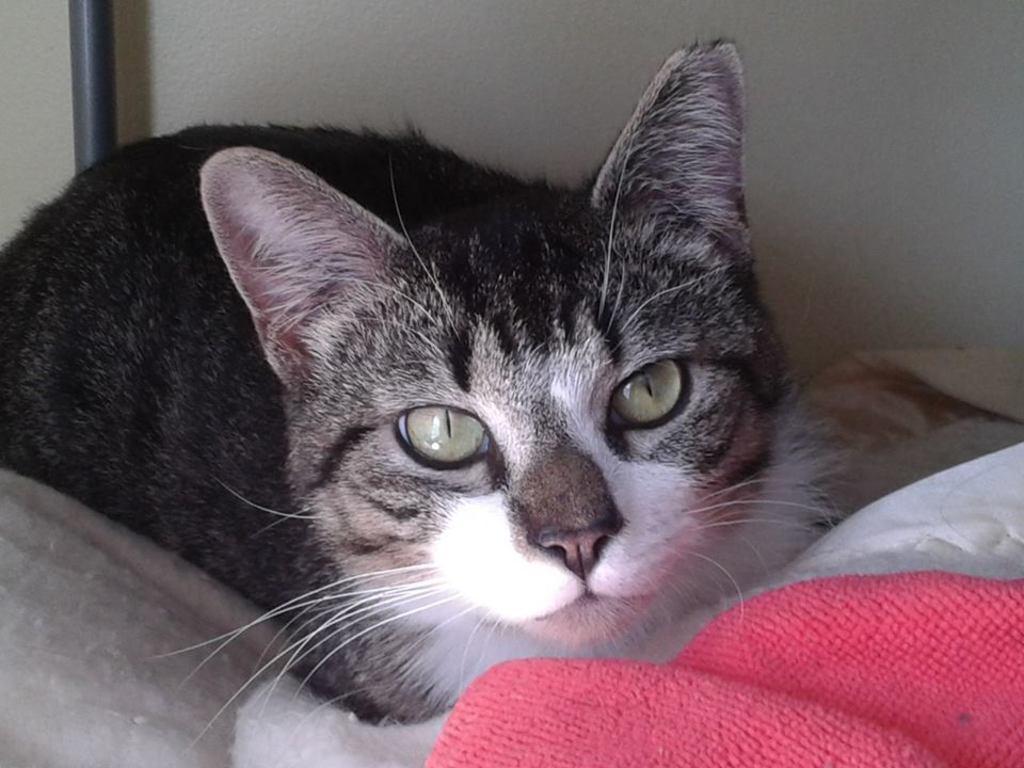Can you describe this image briefly? In this image, we can see a cat is laying on the cloth. Background we can see wall, rod. At the bottom, we can see pink cloth. 